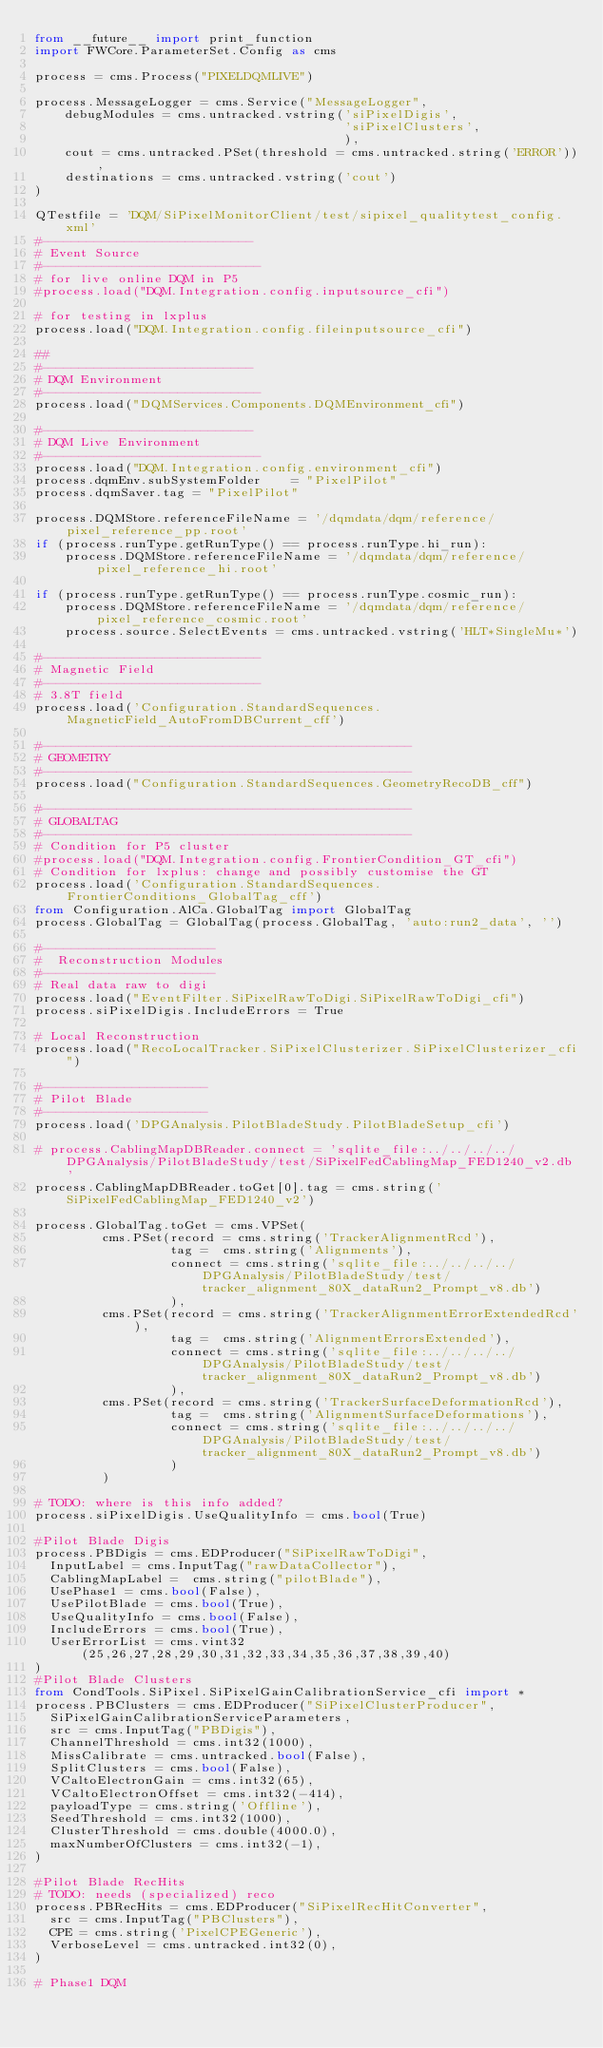<code> <loc_0><loc_0><loc_500><loc_500><_Python_>from __future__ import print_function
import FWCore.ParameterSet.Config as cms

process = cms.Process("PIXELDQMLIVE")

process.MessageLogger = cms.Service("MessageLogger",
    debugModules = cms.untracked.vstring('siPixelDigis', 
                                         'siPixelClusters', 
                                         ),
    cout = cms.untracked.PSet(threshold = cms.untracked.string('ERROR')),
    destinations = cms.untracked.vstring('cout')
)

QTestfile = 'DQM/SiPixelMonitorClient/test/sipixel_qualitytest_config.xml'
#----------------------------
# Event Source
#-----------------------------
# for live online DQM in P5
#process.load("DQM.Integration.config.inputsource_cfi")

# for testing in lxplus
process.load("DQM.Integration.config.fileinputsource_cfi")

##
#----------------------------
# DQM Environment
#-----------------------------
process.load("DQMServices.Components.DQMEnvironment_cfi")

#----------------------------
# DQM Live Environment
#-----------------------------
process.load("DQM.Integration.config.environment_cfi")
process.dqmEnv.subSystemFolder    = "PixelPilot"
process.dqmSaver.tag = "PixelPilot"

process.DQMStore.referenceFileName = '/dqmdata/dqm/reference/pixel_reference_pp.root'
if (process.runType.getRunType() == process.runType.hi_run):
    process.DQMStore.referenceFileName = '/dqmdata/dqm/reference/pixel_reference_hi.root'

if (process.runType.getRunType() == process.runType.cosmic_run):
    process.DQMStore.referenceFileName = '/dqmdata/dqm/reference/pixel_reference_cosmic.root'
    process.source.SelectEvents = cms.untracked.vstring('HLT*SingleMu*')

#-----------------------------
# Magnetic Field
#-----------------------------
# 3.8T field
process.load('Configuration.StandardSequences.MagneticField_AutoFromDBCurrent_cff')

#-------------------------------------------------
# GEOMETRY
#-------------------------------------------------
process.load("Configuration.StandardSequences.GeometryRecoDB_cff")

#-------------------------------------------------
# GLOBALTAG
#-------------------------------------------------
# Condition for P5 cluster
#process.load("DQM.Integration.config.FrontierCondition_GT_cfi")
# Condition for lxplus: change and possibly customise the GT
process.load('Configuration.StandardSequences.FrontierConditions_GlobalTag_cff')
from Configuration.AlCa.GlobalTag import GlobalTag
process.GlobalTag = GlobalTag(process.GlobalTag, 'auto:run2_data', '')

#-----------------------
#  Reconstruction Modules
#-----------------------
# Real data raw to digi
process.load("EventFilter.SiPixelRawToDigi.SiPixelRawToDigi_cfi")
process.siPixelDigis.IncludeErrors = True

# Local Reconstruction
process.load("RecoLocalTracker.SiPixelClusterizer.SiPixelClusterizer_cfi")

#----------------------
# Pilot Blade
#----------------------
process.load('DPGAnalysis.PilotBladeStudy.PilotBladeSetup_cfi')

# process.CablingMapDBReader.connect = 'sqlite_file:../../../../DPGAnalysis/PilotBladeStudy/test/SiPixelFedCablingMap_FED1240_v2.db'
process.CablingMapDBReader.toGet[0].tag = cms.string('SiPixelFedCablingMap_FED1240_v2') 

process.GlobalTag.toGet = cms.VPSet(
         cms.PSet(record = cms.string('TrackerAlignmentRcd'),
                  tag =  cms.string('Alignments'),
                  connect = cms.string('sqlite_file:../../../../DPGAnalysis/PilotBladeStudy/test/tracker_alignment_80X_dataRun2_Prompt_v8.db')
                  ),
         cms.PSet(record = cms.string('TrackerAlignmentErrorExtendedRcd'),
                  tag =  cms.string('AlignmentErrorsExtended'),
                  connect = cms.string('sqlite_file:../../../../DPGAnalysis/PilotBladeStudy/test/tracker_alignment_80X_dataRun2_Prompt_v8.db')
                  ),
         cms.PSet(record = cms.string('TrackerSurfaceDeformationRcd'),
                  tag =  cms.string('AlignmentSurfaceDeformations'),
                  connect = cms.string('sqlite_file:../../../../DPGAnalysis/PilotBladeStudy/test/tracker_alignment_80X_dataRun2_Prompt_v8.db')
                  )
         )

# TODO: where is this info added?
process.siPixelDigis.UseQualityInfo = cms.bool(True)

#Pilot Blade Digis
process.PBDigis = cms.EDProducer("SiPixelRawToDigi",
  InputLabel = cms.InputTag("rawDataCollector"),
  CablingMapLabel =  cms.string("pilotBlade"),
  UsePhase1 = cms.bool(False),
  UsePilotBlade = cms.bool(True),
  UseQualityInfo = cms.bool(False),
  IncludeErrors = cms.bool(True),
  UserErrorList = cms.vint32(25,26,27,28,29,30,31,32,33,34,35,36,37,38,39,40)
)
#Pilot Blade Clusters
from CondTools.SiPixel.SiPixelGainCalibrationService_cfi import *
process.PBClusters = cms.EDProducer("SiPixelClusterProducer",
  SiPixelGainCalibrationServiceParameters,
  src = cms.InputTag("PBDigis"),
  ChannelThreshold = cms.int32(1000),
  MissCalibrate = cms.untracked.bool(False),
  SplitClusters = cms.bool(False),
  VCaltoElectronGain = cms.int32(65),
  VCaltoElectronOffset = cms.int32(-414),                          
  payloadType = cms.string('Offline'),
  SeedThreshold = cms.int32(1000),
  ClusterThreshold = cms.double(4000.0),
  maxNumberOfClusters = cms.int32(-1),
)

#Pilot Blade RecHits
# TODO: needs (specialized) reco
process.PBRecHits = cms.EDProducer("SiPixelRecHitConverter",
  src = cms.InputTag("PBClusters"),
  CPE = cms.string('PixelCPEGeneric'),
  VerboseLevel = cms.untracked.int32(0),
)

# Phase1 DQM
</code> 